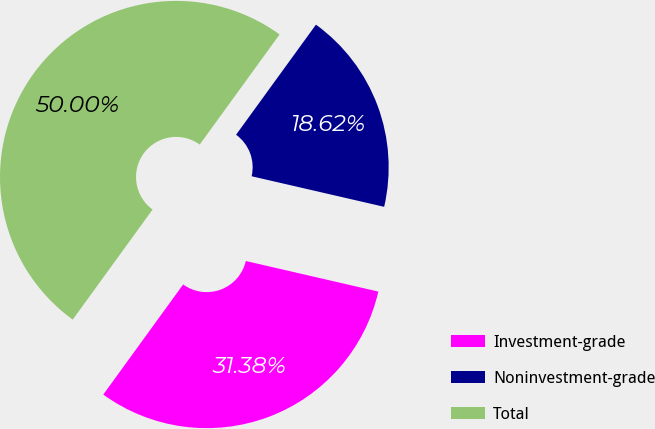Convert chart to OTSL. <chart><loc_0><loc_0><loc_500><loc_500><pie_chart><fcel>Investment-grade<fcel>Noninvestment-grade<fcel>Total<nl><fcel>31.38%<fcel>18.62%<fcel>50.0%<nl></chart> 